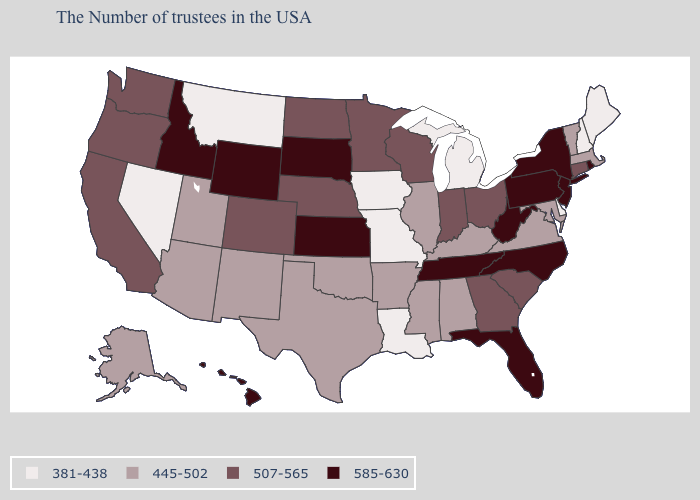What is the value of Kentucky?
Quick response, please. 445-502. Name the states that have a value in the range 381-438?
Short answer required. Maine, New Hampshire, Delaware, Michigan, Louisiana, Missouri, Iowa, Montana, Nevada. What is the value of Hawaii?
Give a very brief answer. 585-630. What is the value of California?
Quick response, please. 507-565. Name the states that have a value in the range 585-630?
Be succinct. Rhode Island, New York, New Jersey, Pennsylvania, North Carolina, West Virginia, Florida, Tennessee, Kansas, South Dakota, Wyoming, Idaho, Hawaii. What is the lowest value in states that border Wisconsin?
Short answer required. 381-438. What is the value of New Mexico?
Concise answer only. 445-502. Among the states that border Alabama , which have the highest value?
Be succinct. Florida, Tennessee. Name the states that have a value in the range 507-565?
Answer briefly. Connecticut, South Carolina, Ohio, Georgia, Indiana, Wisconsin, Minnesota, Nebraska, North Dakota, Colorado, California, Washington, Oregon. What is the lowest value in the South?
Answer briefly. 381-438. What is the lowest value in states that border Arizona?
Quick response, please. 381-438. What is the highest value in states that border Vermont?
Concise answer only. 585-630. What is the highest value in the USA?
Concise answer only. 585-630. Name the states that have a value in the range 507-565?
Write a very short answer. Connecticut, South Carolina, Ohio, Georgia, Indiana, Wisconsin, Minnesota, Nebraska, North Dakota, Colorado, California, Washington, Oregon. Which states have the highest value in the USA?
Give a very brief answer. Rhode Island, New York, New Jersey, Pennsylvania, North Carolina, West Virginia, Florida, Tennessee, Kansas, South Dakota, Wyoming, Idaho, Hawaii. 